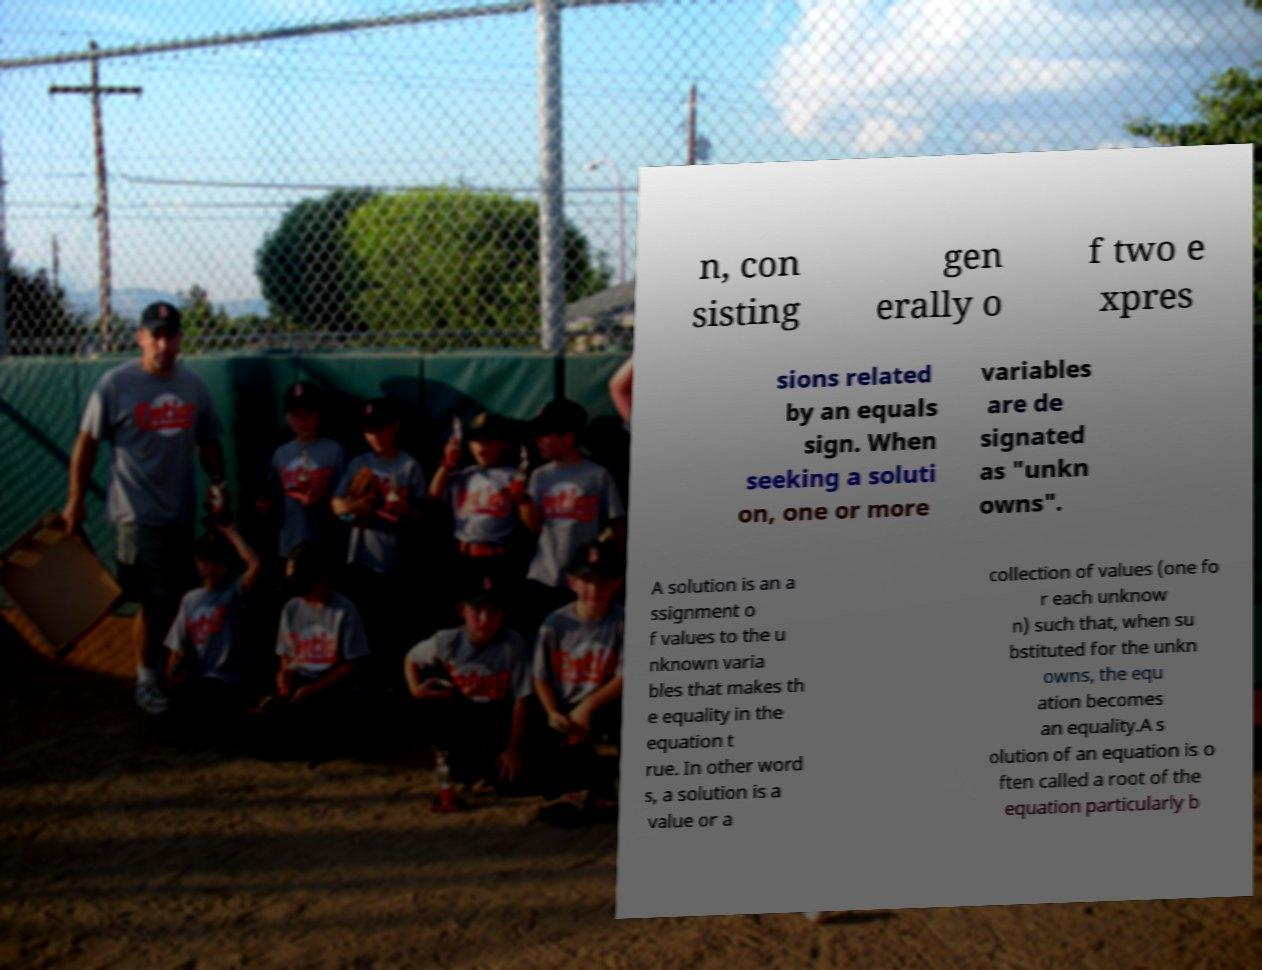Please read and relay the text visible in this image. What does it say? n, con sisting gen erally o f two e xpres sions related by an equals sign. When seeking a soluti on, one or more variables are de signated as "unkn owns". A solution is an a ssignment o f values to the u nknown varia bles that makes th e equality in the equation t rue. In other word s, a solution is a value or a collection of values (one fo r each unknow n) such that, when su bstituted for the unkn owns, the equ ation becomes an equality.A s olution of an equation is o ften called a root of the equation particularly b 